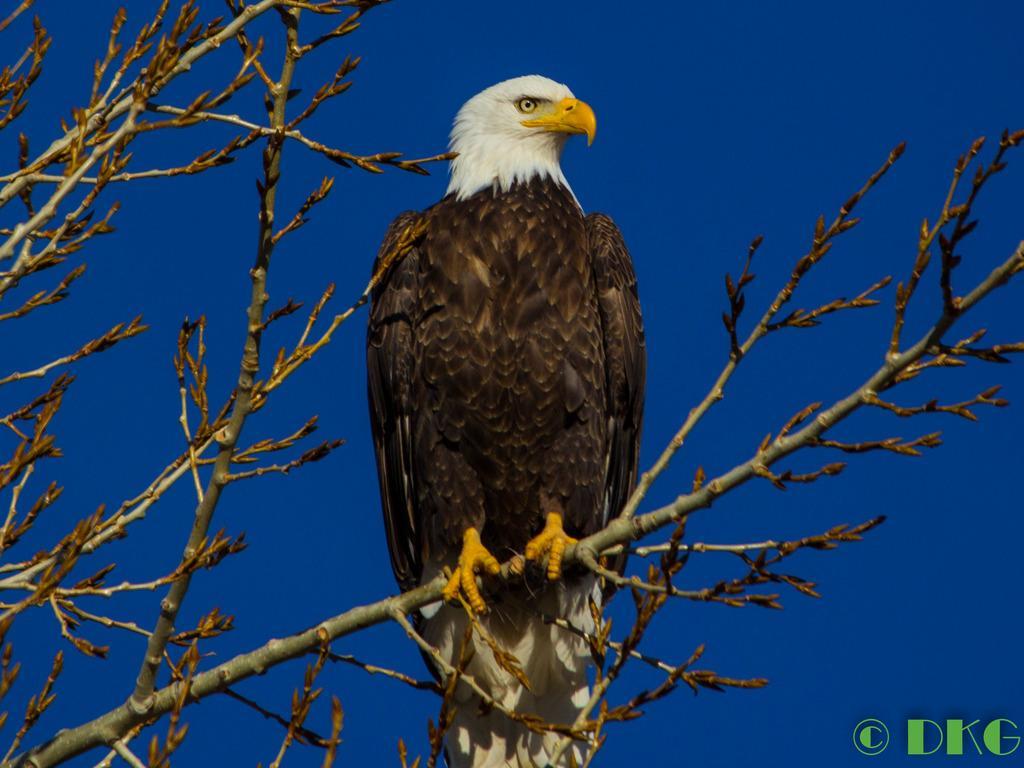Describe this image in one or two sentences. In the picture we can see an eagle sitting on the part of the dried tree stem and behind it, we can see the sky which is blue in color. 